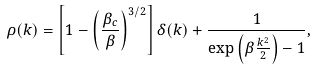Convert formula to latex. <formula><loc_0><loc_0><loc_500><loc_500>\rho ( { k } ) = \left [ 1 - \left ( \frac { \beta _ { c } } { \beta } \right ) ^ { 3 / 2 } \right ] \delta ( { k } ) + \frac { 1 } { \exp \left ( \beta \frac { k ^ { 2 } } { 2 } \right ) - 1 } ,</formula> 